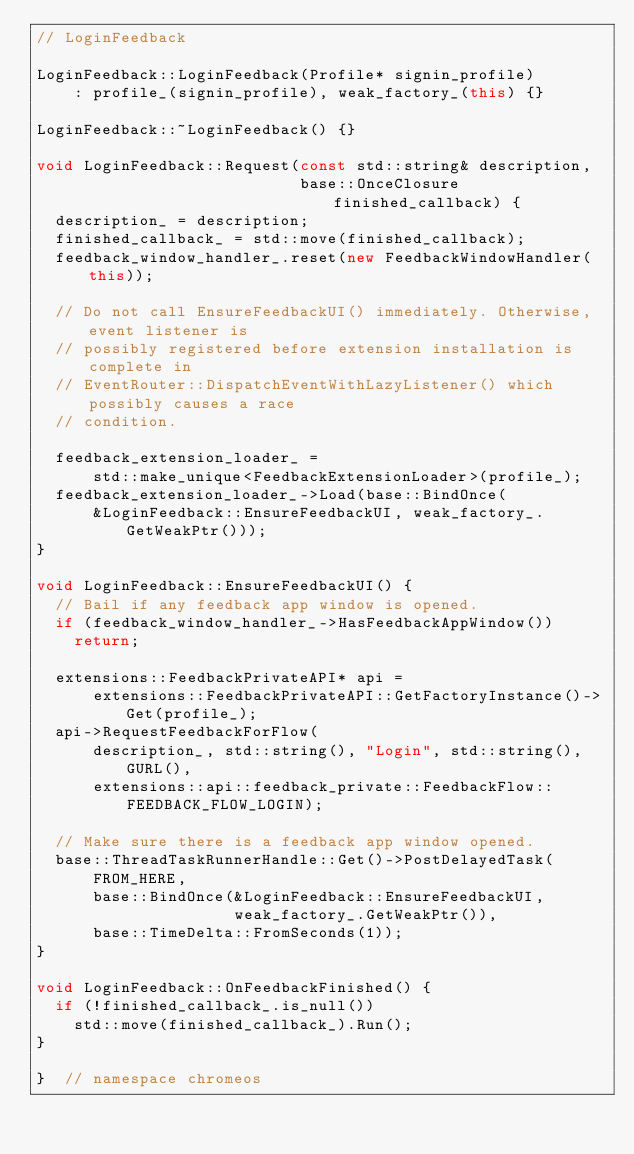<code> <loc_0><loc_0><loc_500><loc_500><_C++_>// LoginFeedback

LoginFeedback::LoginFeedback(Profile* signin_profile)
    : profile_(signin_profile), weak_factory_(this) {}

LoginFeedback::~LoginFeedback() {}

void LoginFeedback::Request(const std::string& description,
                            base::OnceClosure finished_callback) {
  description_ = description;
  finished_callback_ = std::move(finished_callback);
  feedback_window_handler_.reset(new FeedbackWindowHandler(this));

  // Do not call EnsureFeedbackUI() immediately. Otherwise, event listener is
  // possibly registered before extension installation is complete in
  // EventRouter::DispatchEventWithLazyListener() which possibly causes a race
  // condition.

  feedback_extension_loader_ =
      std::make_unique<FeedbackExtensionLoader>(profile_);
  feedback_extension_loader_->Load(base::BindOnce(
      &LoginFeedback::EnsureFeedbackUI, weak_factory_.GetWeakPtr()));
}

void LoginFeedback::EnsureFeedbackUI() {
  // Bail if any feedback app window is opened.
  if (feedback_window_handler_->HasFeedbackAppWindow())
    return;

  extensions::FeedbackPrivateAPI* api =
      extensions::FeedbackPrivateAPI::GetFactoryInstance()->Get(profile_);
  api->RequestFeedbackForFlow(
      description_, std::string(), "Login", std::string(), GURL(),
      extensions::api::feedback_private::FeedbackFlow::FEEDBACK_FLOW_LOGIN);

  // Make sure there is a feedback app window opened.
  base::ThreadTaskRunnerHandle::Get()->PostDelayedTask(
      FROM_HERE,
      base::BindOnce(&LoginFeedback::EnsureFeedbackUI,
                     weak_factory_.GetWeakPtr()),
      base::TimeDelta::FromSeconds(1));
}

void LoginFeedback::OnFeedbackFinished() {
  if (!finished_callback_.is_null())
    std::move(finished_callback_).Run();
}

}  // namespace chromeos
</code> 